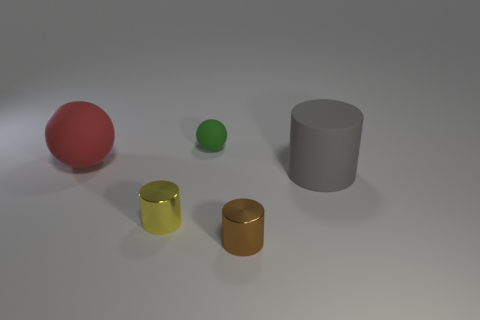Do the big rubber cylinder and the tiny ball have the same color?
Provide a short and direct response. No. Is the number of green matte spheres that are behind the green ball less than the number of small green balls?
Your answer should be compact. Yes. Is the large cylinder made of the same material as the red ball?
Your answer should be very brief. Yes. How many red balls are the same material as the large gray object?
Provide a succinct answer. 1. There is a cylinder that is the same material as the large red ball; what is its color?
Provide a succinct answer. Gray. What is the shape of the gray thing?
Provide a short and direct response. Cylinder. There is a object on the right side of the tiny brown metal thing; what material is it?
Your answer should be compact. Rubber. Is there a large cylinder of the same color as the small matte ball?
Your answer should be compact. No. There is a metallic thing that is the same size as the brown shiny cylinder; what shape is it?
Offer a very short reply. Cylinder. There is a tiny metal cylinder that is right of the small green rubber ball; what is its color?
Your answer should be compact. Brown. 